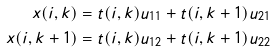Convert formula to latex. <formula><loc_0><loc_0><loc_500><loc_500>x ( i , k ) & = t ( i , k ) u _ { 1 1 } + t ( i , k + 1 ) u _ { 2 1 } \\ x ( i , k + 1 ) & = t ( i , k ) u _ { 1 2 } + t ( i , k + 1 ) u _ { 2 2 }</formula> 